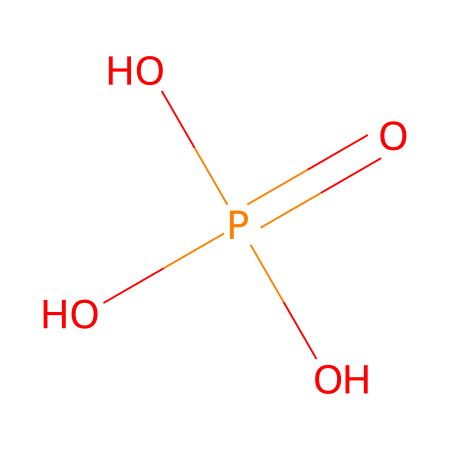What is the total number of oxygen atoms in this compound? The chemical structure shows that there are three oxygen atoms attached to the phosphorus atom. Count each "O" in the SMILES string to confirm this.
Answer: three What is the central atom in this chemical structure? The central atom is identified by its bond to multiple oxygen atoms. In this case, phosphorus is the atom surrounded by the oxygen atoms.
Answer: phosphorus How many total single bonds are present in this chemical? By examining the structure, we identify that phosphorus is connected to three oxygen atoms with single bonds and one double bond with one oxygen, leading to a total of three single bonds in the compound.
Answer: three What type of phosphate is represented by this structure? The presence of one phosphorus atom bonded to four oxygen atoms, with one being part of a double bond, indicates that this is a phosphate group, specifically a phosphate ion in its acidic form.
Answer: phosphate What is the chemical ion involved when guano phosphates are dissolved in water? The dissociation of guano phosphates in water produces phosphate ions, which carry a negative charge due to the loss of hydrogen ions from the acidic phosphate.
Answer: phosphate ion How many valence electrons does phosphorus have in this compound? Phosphorus has five valence electrons according to its position in group 15 of the periodic table, and in this structure, it uses all five to bond with the surrounding oxygen atoms.
Answer: five What is the role of the double bond in this structure? The double bond to one of the oxygen atoms increases the stability and reactivity of the molecule, indicating that this oxygen participates in the creation of stronger intramolecular interactions in the phosphate ion.
Answer: stability and reactivity 